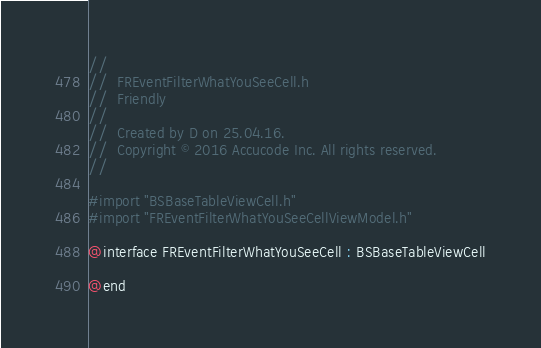<code> <loc_0><loc_0><loc_500><loc_500><_C_>//
//  FREventFilterWhatYouSeeCell.h
//  Friendly
//
//  Created by D on 25.04.16.
//  Copyright © 2016 Accucode Inc. All rights reserved.
//

#import "BSBaseTableViewCell.h"
#import "FREventFilterWhatYouSeeCellViewModel.h"

@interface FREventFilterWhatYouSeeCell : BSBaseTableViewCell

@end
</code> 